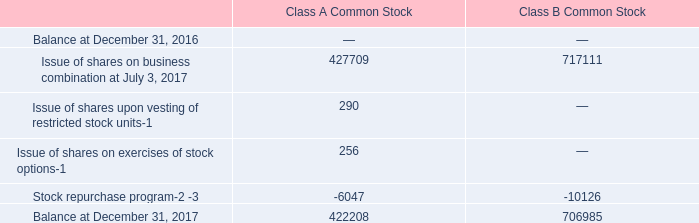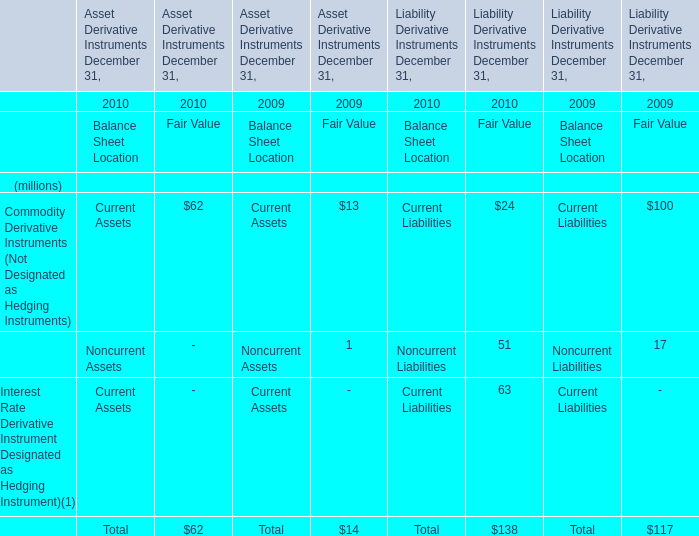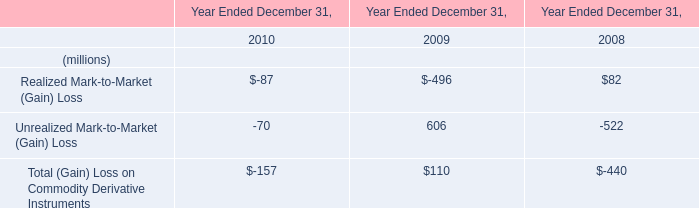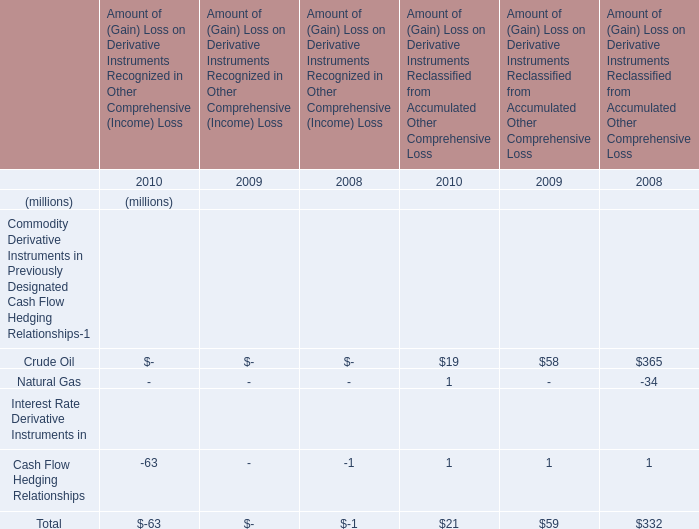What is the difference between 2010 and 2009 's highest Fair Value? (in million) 
Computations: (100 - 24)
Answer: 76.0. 